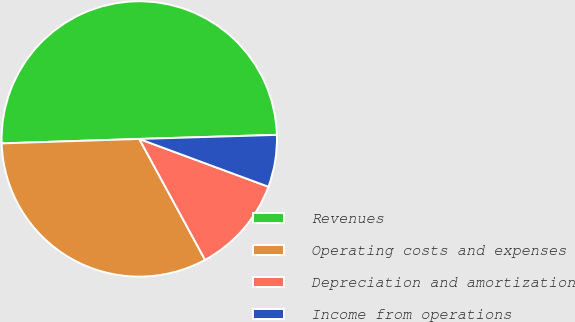Convert chart. <chart><loc_0><loc_0><loc_500><loc_500><pie_chart><fcel>Revenues<fcel>Operating costs and expenses<fcel>Depreciation and amortization<fcel>Income from operations<nl><fcel>50.05%<fcel>32.42%<fcel>11.43%<fcel>6.11%<nl></chart> 